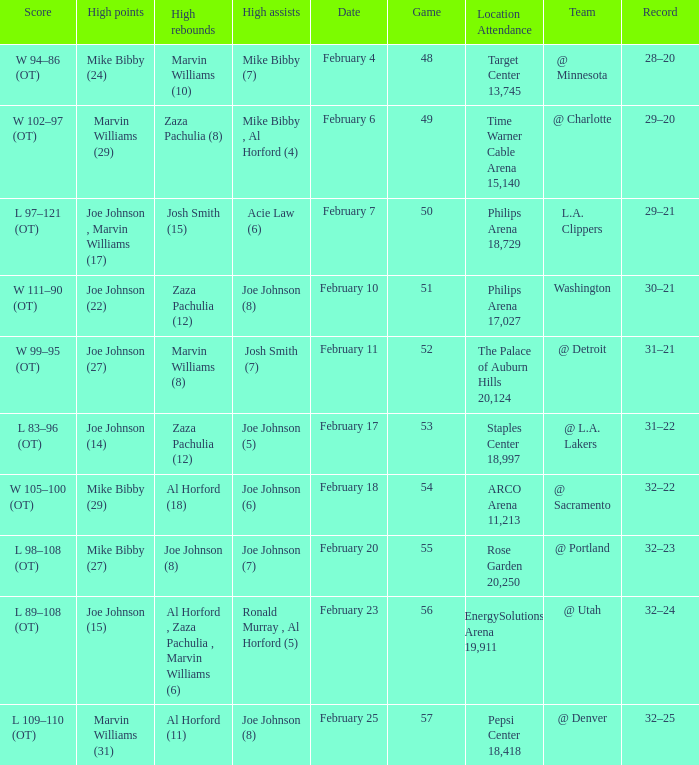Who made high assists on february 4 Mike Bibby (7). 